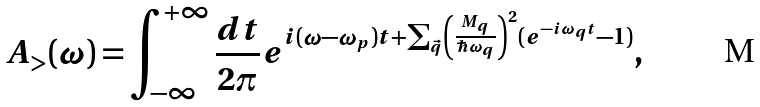Convert formula to latex. <formula><loc_0><loc_0><loc_500><loc_500>A _ { > } ( \omega ) = \int _ { - \infty } ^ { + \infty } \frac { d t } { 2 \pi } e ^ { i ( \omega - \omega _ { p } ) t + \sum _ { \vec { q } } \left ( \frac { M _ { q } } { \hbar { \omega } _ { q } } \right ) ^ { 2 } ( e ^ { - i \omega _ { q } t } - 1 ) } ,</formula> 